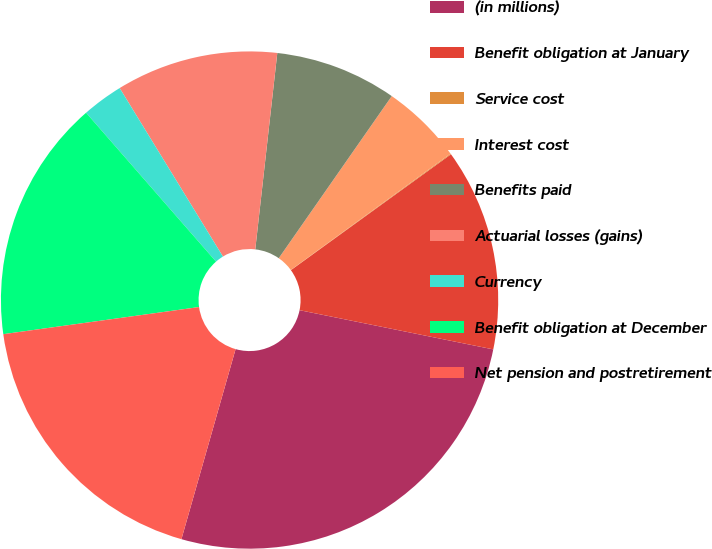<chart> <loc_0><loc_0><loc_500><loc_500><pie_chart><fcel>(in millions)<fcel>Benefit obligation at January<fcel>Service cost<fcel>Interest cost<fcel>Benefits paid<fcel>Actuarial losses (gains)<fcel>Currency<fcel>Benefit obligation at December<fcel>Net pension and postretirement<nl><fcel>26.24%<fcel>13.15%<fcel>0.05%<fcel>5.29%<fcel>7.91%<fcel>10.53%<fcel>2.67%<fcel>15.77%<fcel>18.39%<nl></chart> 